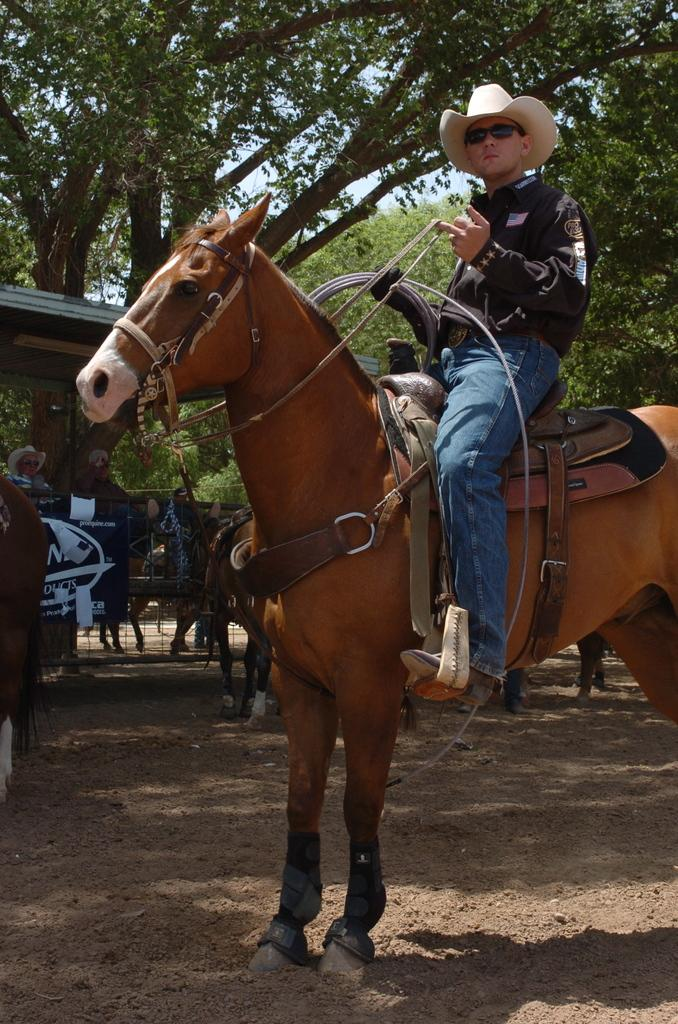What animal is the main subject of the image? There is a horse in the image. What equipment is on the horse? The horse has a saddle. Who is riding the horse? A person is sitting on the horse. What is the person holding? The person is holding a rope. What protective gear is the person wearing? The person is wearing goggles. What type of headwear is the person wearing? The person is wearing a cap. What can be seen in the background of the image? There are horses, trees, and people in the background of the image. What is the price of the fish in the image? There is no fish present in the image, so it is not possible to determine its price. 